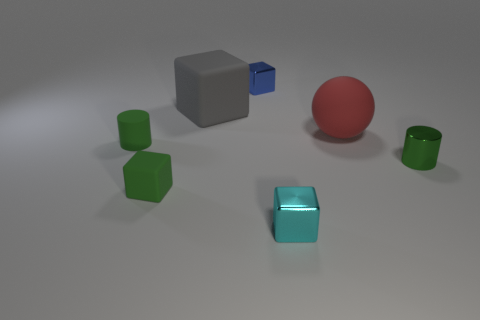Subtract all tiny cubes. How many cubes are left? 1 Subtract 3 cubes. How many cubes are left? 1 Add 1 blue cubes. How many objects exist? 8 Subtract all cubes. How many objects are left? 3 Subtract all green cubes. How many cubes are left? 3 Add 4 green rubber cylinders. How many green rubber cylinders exist? 5 Subtract 0 cyan balls. How many objects are left? 7 Subtract all gray blocks. Subtract all blue cylinders. How many blocks are left? 3 Subtract all green cubes. How many gray cylinders are left? 0 Subtract all large red metallic cubes. Subtract all big rubber objects. How many objects are left? 5 